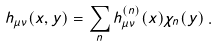<formula> <loc_0><loc_0><loc_500><loc_500>h _ { \mu \nu } ( x , y ) = \sum _ { n } h _ { \mu \nu } ^ { ( n ) } ( x ) \chi _ { n } ( y ) \, .</formula> 